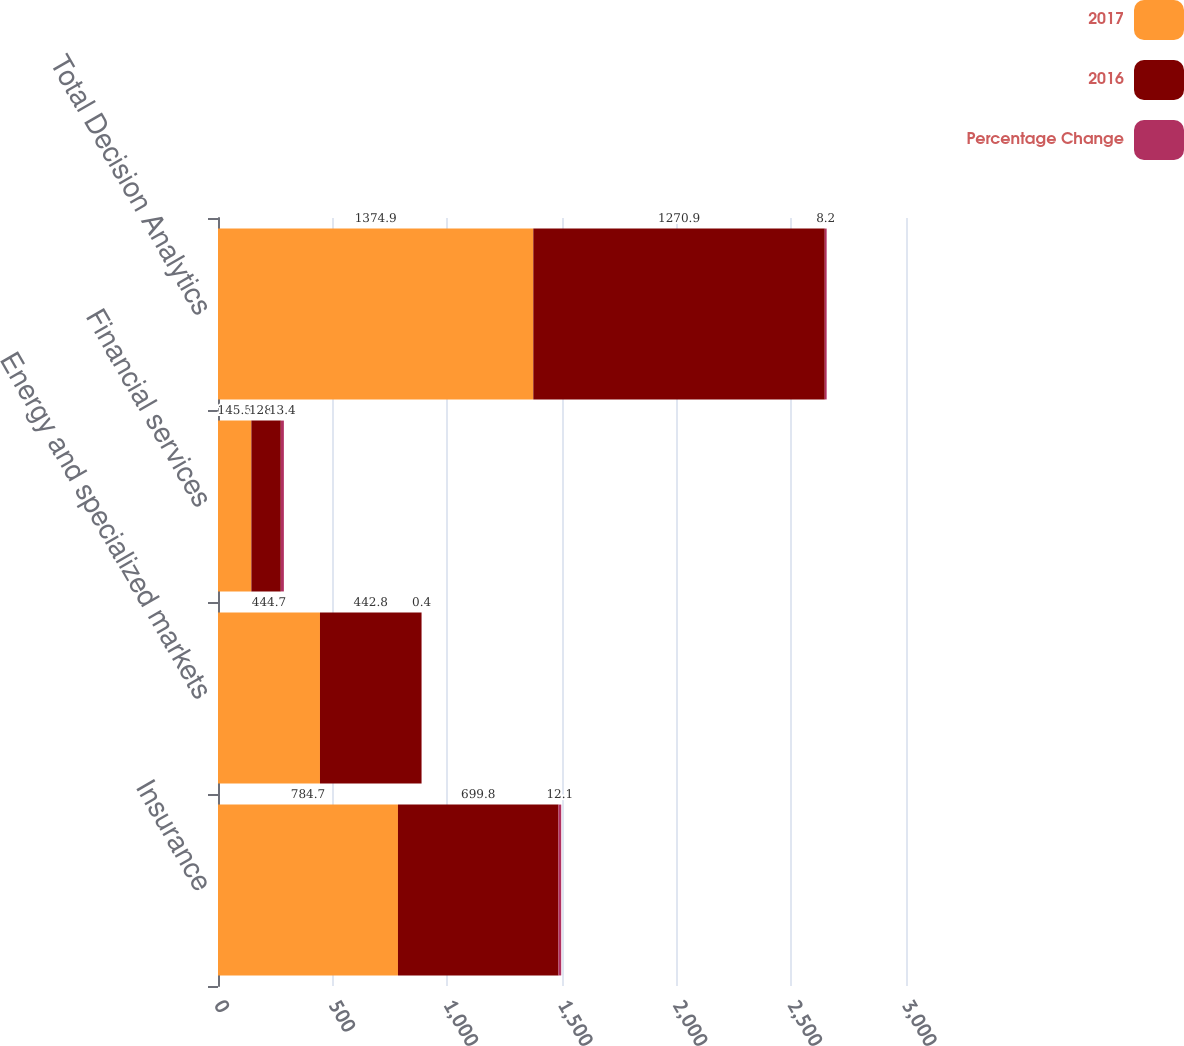<chart> <loc_0><loc_0><loc_500><loc_500><stacked_bar_chart><ecel><fcel>Insurance<fcel>Energy and specialized markets<fcel>Financial services<fcel>Total Decision Analytics<nl><fcel>2017<fcel>784.7<fcel>444.7<fcel>145.5<fcel>1374.9<nl><fcel>2016<fcel>699.8<fcel>442.8<fcel>128.3<fcel>1270.9<nl><fcel>Percentage Change<fcel>12.1<fcel>0.4<fcel>13.4<fcel>8.2<nl></chart> 